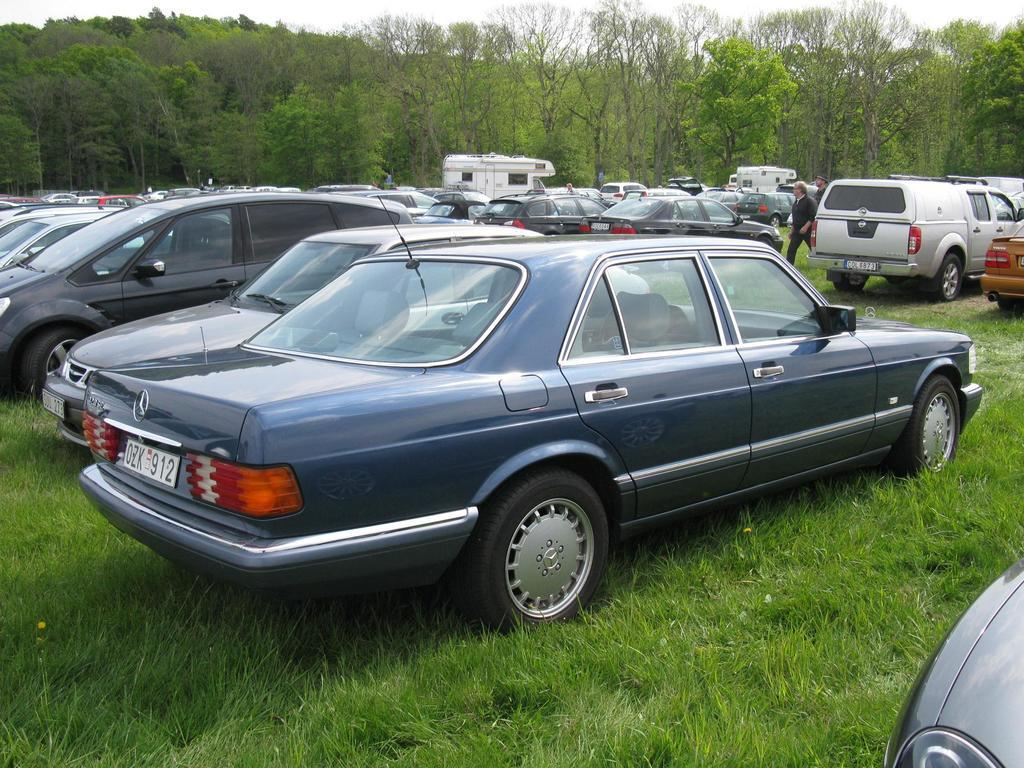Provide a one-sentence caption for the provided image. cars parked in a field and one has a license plate reading OZK 912. 